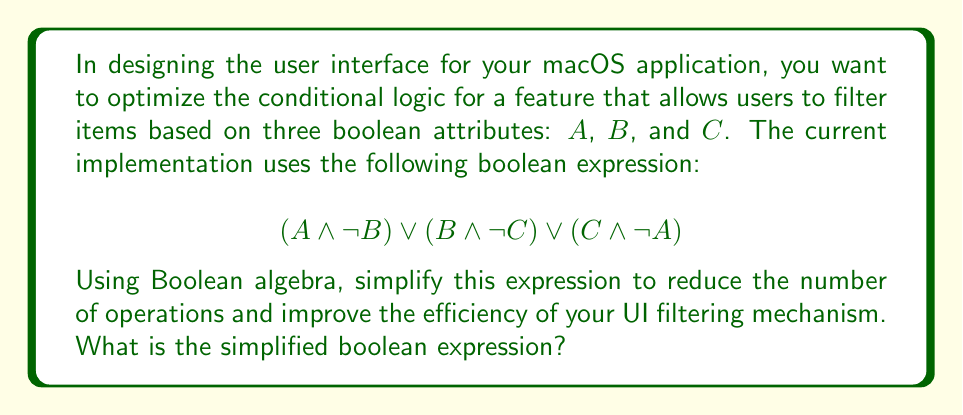Provide a solution to this math problem. Let's simplify the given boolean expression step by step using Boolean algebra laws:

1) Start with the original expression:
   $$(A \land \lnot B) \lor (B \land \lnot C) \lor (C \land \lnot A)$$

2) Expand the expression using the distributive law:
   $$(A \land \lnot B) \lor (B \land \lnot C) \lor (C \land \lnot A)$$
   $$= (A \lor B \lor C) \land (A \lor B \lor \lnot A) \land (A \lor \lnot C \lor C) \land (\lnot B \lor B \lor C) \land (\lnot B \lor \lnot C \lor C) \land (\lnot B \lor \lnot C \lor \lnot A)$$

3) Simplify using the complement law $(X \lor \lnot X = 1)$ and identity law $(X \lor 1 = 1)$:
   $$= (A \lor B \lor C) \land 1 \land 1 \land 1 \land 1 \land (\lnot B \lor \lnot C \lor \lnot A)$$

4) Apply the identity law $(X \land 1 = X)$:
   $$= (A \lor B \lor C) \land (\lnot B \lor \lnot C \lor \lnot A)$$

5) This is the final simplified form. We can verify that this is equivalent to the original expression by expanding it:
   $$(A \land \lnot B) \lor (A \land \lnot C) \lor (B \land \lnot C) \lor (B \land \lnot A) \lor (C \land \lnot A) \lor (C \land \lnot B)$$

   Which is indeed equivalent to the original expression when redundant terms are removed.

This simplified form reduces the number of operations from 5 (3 AND operations and 2 OR operations) in the original expression to 3 (1 AND operation and 2 OR operations) in the simplified version, potentially improving the efficiency of the UI filtering mechanism.
Answer: $$(A \lor B \lor C) \land (\lnot B \lor \lnot C \lor \lnot A)$$ 